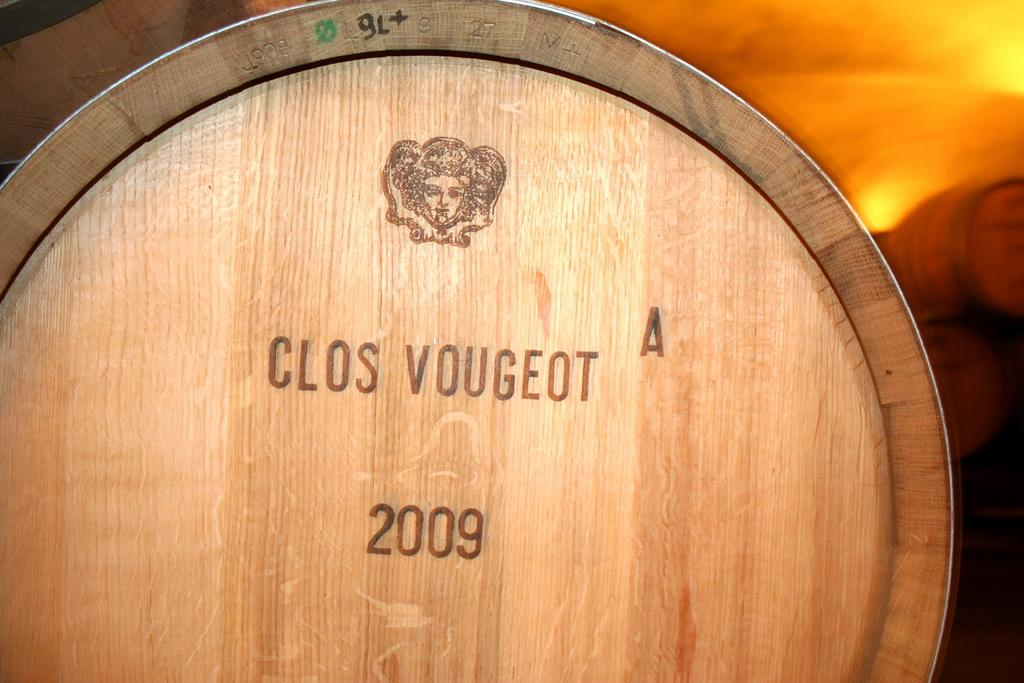<image>
Summarize the visual content of the image. A wooden barrel is labeled Clos Vougeot with the year 2009 on it. 